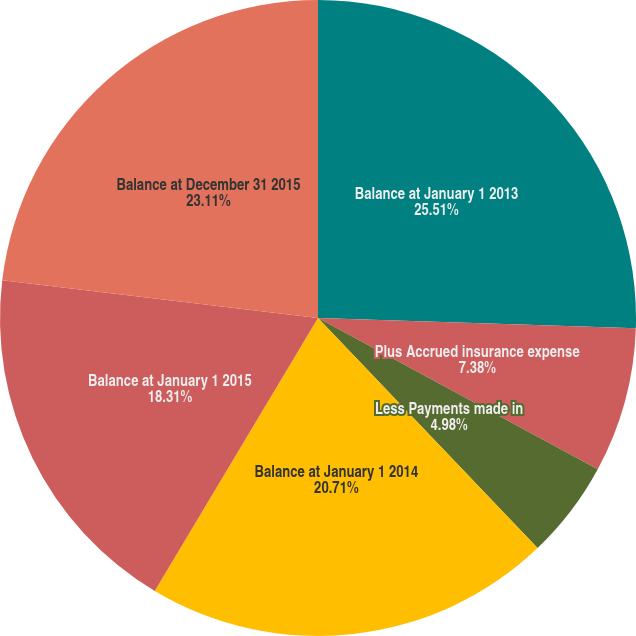Convert chart to OTSL. <chart><loc_0><loc_0><loc_500><loc_500><pie_chart><fcel>Balance at January 1 2013<fcel>Plus Accrued insurance expense<fcel>Less Payments made in<fcel>Balance at January 1 2014<fcel>Balance at January 1 2015<fcel>Balance at December 31 2015<nl><fcel>25.51%<fcel>7.38%<fcel>4.98%<fcel>20.71%<fcel>18.31%<fcel>23.11%<nl></chart> 